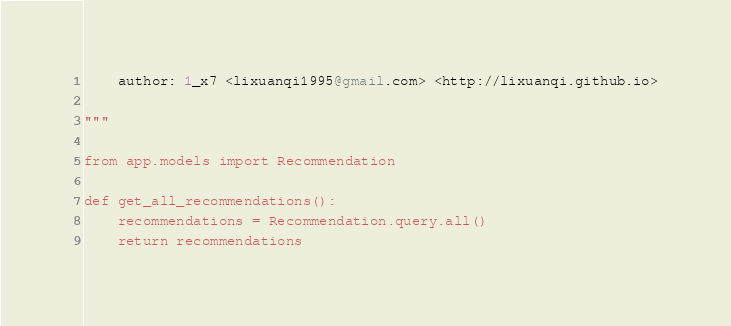Convert code to text. <code><loc_0><loc_0><loc_500><loc_500><_Python_>    author: 1_x7 <lixuanqi1995@gmail.com> <http://lixuanqi.github.io>

"""

from app.models import Recommendation

def get_all_recommendations():
    recommendations = Recommendation.query.all()
    return recommendations</code> 